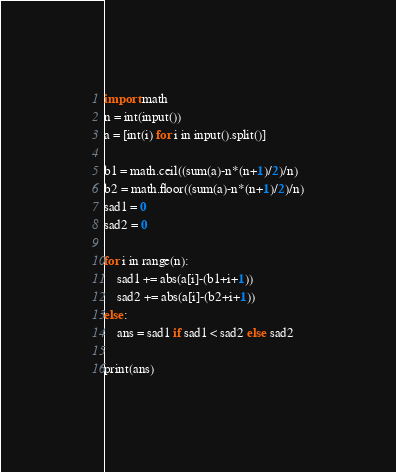<code> <loc_0><loc_0><loc_500><loc_500><_Python_>import math
n = int(input())
a = [int(i) for i in input().split()]

b1 = math.ceil((sum(a)-n*(n+1)/2)/n)
b2 = math.floor((sum(a)-n*(n+1)/2)/n)
sad1 = 0
sad2 = 0

for i in range(n):
    sad1 += abs(a[i]-(b1+i+1))
    sad2 += abs(a[i]-(b2+i+1))
else:
    ans = sad1 if sad1 < sad2 else sad2

print(ans)</code> 